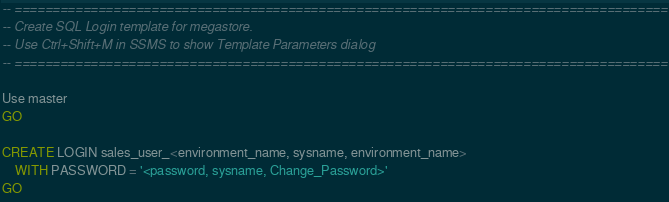Convert code to text. <code><loc_0><loc_0><loc_500><loc_500><_SQL_>-- ======================================================================================
-- Create SQL Login template for megastore.
-- Use Ctrl+Shift+M in SSMS to show Template Parameters dialog
-- ======================================================================================

Use master
GO

CREATE LOGIN sales_user_<environment_name, sysname, environment_name>
	WITH PASSWORD = '<password, sysname, Change_Password>' 
GO
</code> 